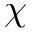Convert formula to latex. <formula><loc_0><loc_0><loc_500><loc_500>\chi</formula> 